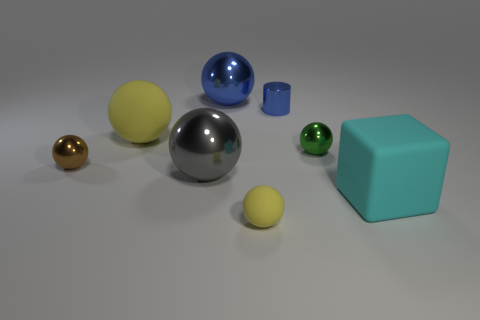What number of tiny things are in front of the tiny metal cylinder and on the right side of the big blue thing?
Ensure brevity in your answer.  2. Are there the same number of small brown balls that are behind the large blue thing and matte objects that are left of the green sphere?
Offer a very short reply. No. Is the size of the yellow rubber sphere behind the green metal sphere the same as the rubber sphere on the right side of the large blue metallic thing?
Provide a short and direct response. No. There is a sphere that is both in front of the tiny brown metallic thing and left of the small yellow matte thing; what is its material?
Your response must be concise. Metal. Are there fewer brown spheres than small things?
Make the answer very short. Yes. What is the size of the yellow rubber sphere to the right of the matte sphere to the left of the tiny yellow ball?
Keep it short and to the point. Small. What shape is the big metal thing in front of the blue ball behind the tiny shiny object to the right of the tiny blue thing?
Ensure brevity in your answer.  Sphere. There is a small thing that is the same material as the big block; what is its color?
Offer a very short reply. Yellow. There is a large rubber object in front of the ball that is to the left of the rubber object that is behind the small brown metallic sphere; what color is it?
Make the answer very short. Cyan. How many cylinders are big cyan objects or blue metallic things?
Make the answer very short. 1. 